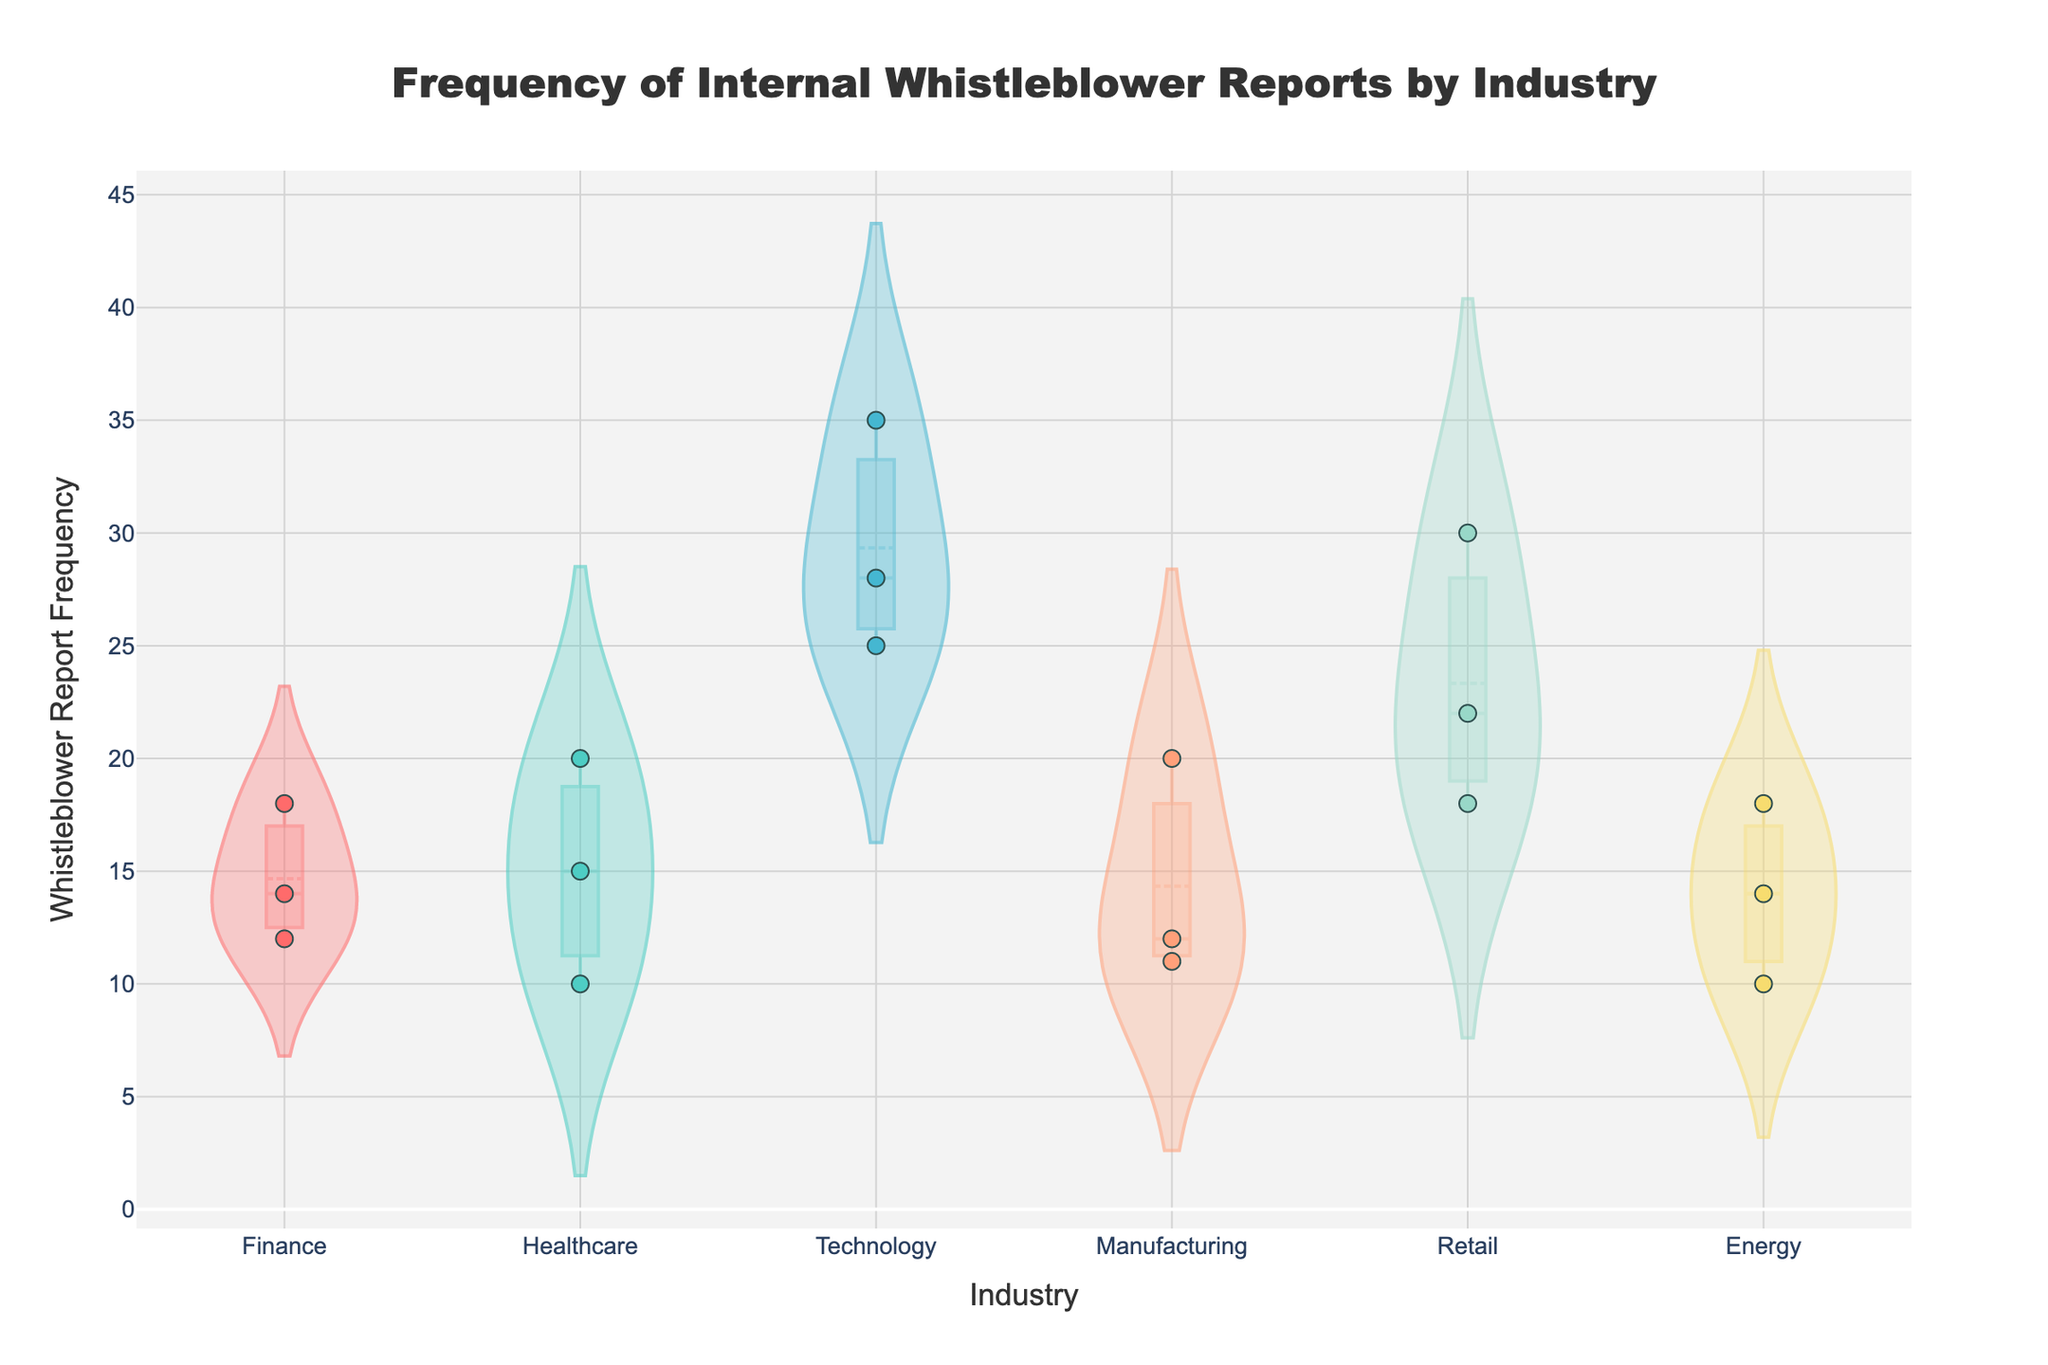What is the title of the figure? The title is written at the top, in a large font for easy visibility. It reads 'Frequency of Internal Whistleblower Reports by Industry'.
Answer: Frequency of Internal Whistleblower Reports by Industry Which industry has the highest frequency of internal whistleblower reports? The figure includes jittered points showing individual data points and violins indicating the distribution. The Technology industry has the highest point at 35 on the y-axis.
Answer: Technology How many industries have at least one substantiated whistleblower report? To determine this, count the industries with any data points labeled as 'Substantiated'. From the jittered points, we see that all industries (Finance, Healthcare, Technology, Manufacturing, Retail, Energy) have at least one substantiated report.
Answer: 6 What is the average whistleblower report frequency in the Retail industry? The Retail industry's points are at 30 (Walmart), 22 (Amazon), and 18 (Costco). (30 + 22 + 18) / 3 = 70 / 3 = 23.33.
Answer: 23.33 Between Finance and Healthcare, which industry has more substantiated reports? By checking the jittered points marked 'Substantiated', we see:
Finance: JP Morgan Chase (18), Bank of America (14) = 2 substantiated reports.
Healthcare: Johnson & Johnson (20), Novartis (10) = 2 substantiated reports.
They have an equal number.
Answer: Equal Which company in the Energy industry has the lowest whistleblower report frequency? The jittered points in the Energy industry show frequencies of 14 (ExxonMobil), 10 (Chevron), and 18 (Shell). Chevron has the lowest frequency.
Answer: Chevron What is the median whistleblower report frequency in the Technology industry? Order the points in Technology (25, 28, 35). The middle value (median) is 28.
Answer: 28 In which industry are the report outcomes more likely to be unsubstantiated? Compare the ratio of unsubstantiated to total points in each industry. Technology shows more unsubstantiated points (Google, Microsoft) compared to substantiated (Apple), suggesting a higher likelihood of unsubstantiated outcomes.
Answer: Technology Which industry has the least variation in whistleblower report frequency? Violin plots give a visual representation of data distribution. Healthcare's plot appears narrower, suggesting less variation.
Answer: Healthcare 